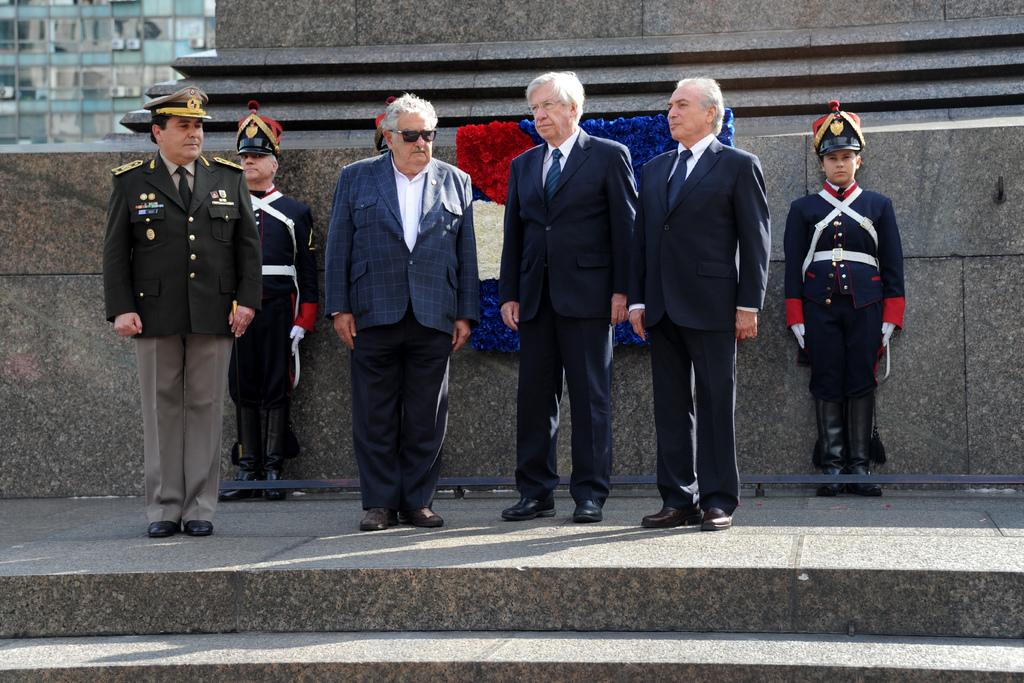What can be seen in the center of the image? There are men standing in the center of the image. What architectural feature is present in the foreground of the image? There is a staircase in the foreground of the image. What is happening in the background of the image? There is a construction in the background of the image. What type of structure is visible at the top left of the image? There is a building visible at the top left of the image. What thought is the man on the left having in the image? There is no information about the thoughts of the men in the image, as it only shows their physical appearance and location. What type of voyage are the men embarking on in the image? There is no indication of a voyage in the image; the men are simply standing in the center. 